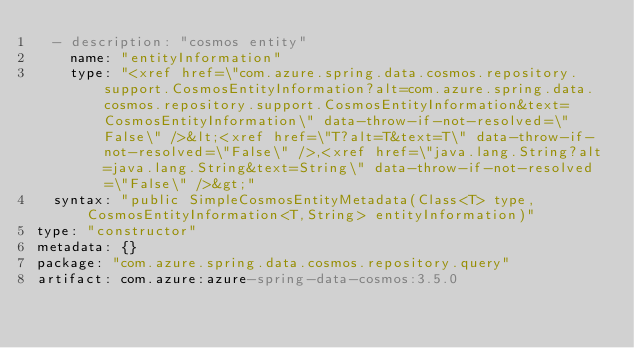Convert code to text. <code><loc_0><loc_0><loc_500><loc_500><_YAML_>  - description: "cosmos entity"
    name: "entityInformation"
    type: "<xref href=\"com.azure.spring.data.cosmos.repository.support.CosmosEntityInformation?alt=com.azure.spring.data.cosmos.repository.support.CosmosEntityInformation&text=CosmosEntityInformation\" data-throw-if-not-resolved=\"False\" />&lt;<xref href=\"T?alt=T&text=T\" data-throw-if-not-resolved=\"False\" />,<xref href=\"java.lang.String?alt=java.lang.String&text=String\" data-throw-if-not-resolved=\"False\" />&gt;"
  syntax: "public SimpleCosmosEntityMetadata(Class<T> type, CosmosEntityInformation<T,String> entityInformation)"
type: "constructor"
metadata: {}
package: "com.azure.spring.data.cosmos.repository.query"
artifact: com.azure:azure-spring-data-cosmos:3.5.0
</code> 